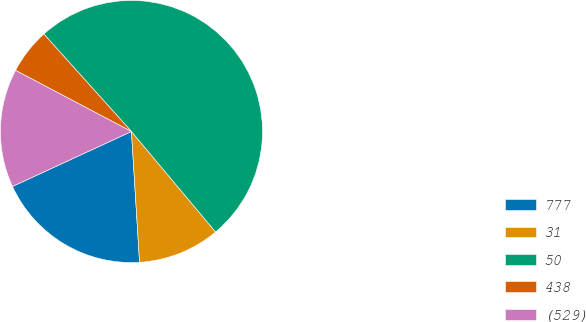Convert chart. <chart><loc_0><loc_0><loc_500><loc_500><pie_chart><fcel>777<fcel>31<fcel>50<fcel>438<fcel>(529)<nl><fcel>19.1%<fcel>10.11%<fcel>50.56%<fcel>5.62%<fcel>14.61%<nl></chart> 